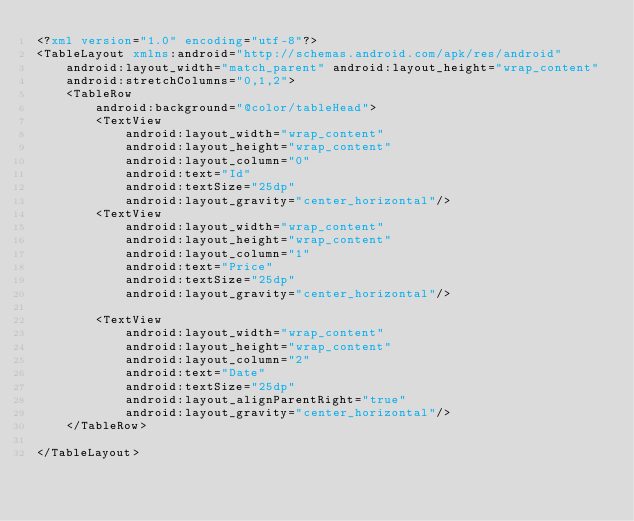Convert code to text. <code><loc_0><loc_0><loc_500><loc_500><_XML_><?xml version="1.0" encoding="utf-8"?>
<TableLayout xmlns:android="http://schemas.android.com/apk/res/android"
    android:layout_width="match_parent" android:layout_height="wrap_content"
    android:stretchColumns="0,1,2">
    <TableRow
        android:background="@color/tableHead">
        <TextView
            android:layout_width="wrap_content"
            android:layout_height="wrap_content"
            android:layout_column="0"
            android:text="Id"
            android:textSize="25dp"
            android:layout_gravity="center_horizontal"/>
        <TextView
            android:layout_width="wrap_content"
            android:layout_height="wrap_content"
            android:layout_column="1"
            android:text="Price"
            android:textSize="25dp"
            android:layout_gravity="center_horizontal"/>

        <TextView
            android:layout_width="wrap_content"
            android:layout_height="wrap_content"
            android:layout_column="2"
            android:text="Date"
            android:textSize="25dp"
            android:layout_alignParentRight="true"
            android:layout_gravity="center_horizontal"/>
    </TableRow>

</TableLayout></code> 